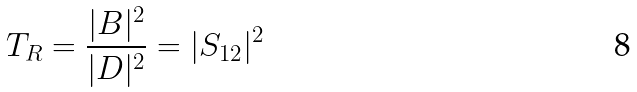Convert formula to latex. <formula><loc_0><loc_0><loc_500><loc_500>T _ { R } = \frac { | B | ^ { 2 } } { | D | ^ { 2 } } = | S _ { 1 2 } | ^ { 2 }</formula> 